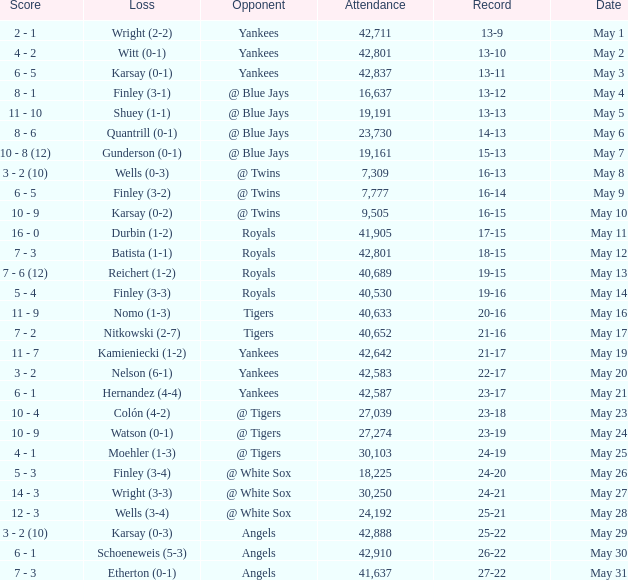Parse the table in full. {'header': ['Score', 'Loss', 'Opponent', 'Attendance', 'Record', 'Date'], 'rows': [['2 - 1', 'Wright (2-2)', 'Yankees', '42,711', '13-9', 'May 1'], ['4 - 2', 'Witt (0-1)', 'Yankees', '42,801', '13-10', 'May 2'], ['6 - 5', 'Karsay (0-1)', 'Yankees', '42,837', '13-11', 'May 3'], ['8 - 1', 'Finley (3-1)', '@ Blue Jays', '16,637', '13-12', 'May 4'], ['11 - 10', 'Shuey (1-1)', '@ Blue Jays', '19,191', '13-13', 'May 5'], ['8 - 6', 'Quantrill (0-1)', '@ Blue Jays', '23,730', '14-13', 'May 6'], ['10 - 8 (12)', 'Gunderson (0-1)', '@ Blue Jays', '19,161', '15-13', 'May 7'], ['3 - 2 (10)', 'Wells (0-3)', '@ Twins', '7,309', '16-13', 'May 8'], ['6 - 5', 'Finley (3-2)', '@ Twins', '7,777', '16-14', 'May 9'], ['10 - 9', 'Karsay (0-2)', '@ Twins', '9,505', '16-15', 'May 10'], ['16 - 0', 'Durbin (1-2)', 'Royals', '41,905', '17-15', 'May 11'], ['7 - 3', 'Batista (1-1)', 'Royals', '42,801', '18-15', 'May 12'], ['7 - 6 (12)', 'Reichert (1-2)', 'Royals', '40,689', '19-15', 'May 13'], ['5 - 4', 'Finley (3-3)', 'Royals', '40,530', '19-16', 'May 14'], ['11 - 9', 'Nomo (1-3)', 'Tigers', '40,633', '20-16', 'May 16'], ['7 - 2', 'Nitkowski (2-7)', 'Tigers', '40,652', '21-16', 'May 17'], ['11 - 7', 'Kamieniecki (1-2)', 'Yankees', '42,642', '21-17', 'May 19'], ['3 - 2', 'Nelson (6-1)', 'Yankees', '42,583', '22-17', 'May 20'], ['6 - 1', 'Hernandez (4-4)', 'Yankees', '42,587', '23-17', 'May 21'], ['10 - 4', 'Colón (4-2)', '@ Tigers', '27,039', '23-18', 'May 23'], ['10 - 9', 'Watson (0-1)', '@ Tigers', '27,274', '23-19', 'May 24'], ['4 - 1', 'Moehler (1-3)', '@ Tigers', '30,103', '24-19', 'May 25'], ['5 - 3', 'Finley (3-4)', '@ White Sox', '18,225', '24-20', 'May 26'], ['14 - 3', 'Wright (3-3)', '@ White Sox', '30,250', '24-21', 'May 27'], ['12 - 3', 'Wells (3-4)', '@ White Sox', '24,192', '25-21', 'May 28'], ['3 - 2 (10)', 'Karsay (0-3)', 'Angels', '42,888', '25-22', 'May 29'], ['6 - 1', 'Schoeneweis (5-3)', 'Angels', '42,910', '26-22', 'May 30'], ['7 - 3', 'Etherton (0-1)', 'Angels', '41,637', '27-22', 'May 31']]} What is the attendance for the game on May 25? 30103.0. 